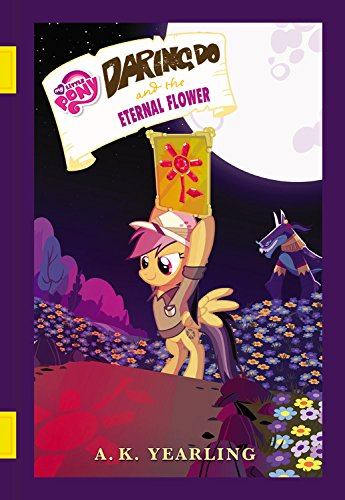What is the title of this book? The full title of the book depicted in the image is 'My Little Pony: Daring Do and the Eternal Flower,' which is part of a popular series for children. 